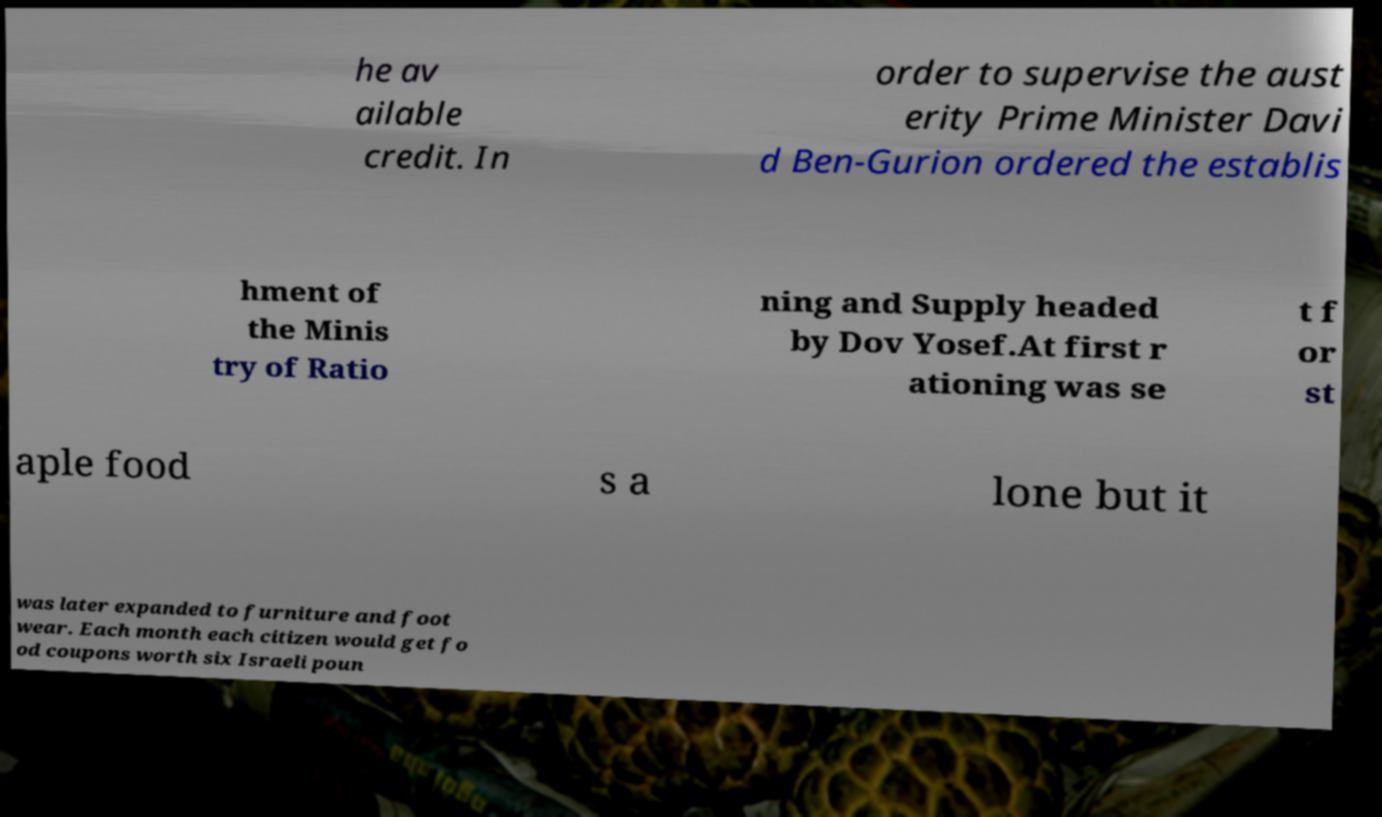For documentation purposes, I need the text within this image transcribed. Could you provide that? he av ailable credit. In order to supervise the aust erity Prime Minister Davi d Ben-Gurion ordered the establis hment of the Minis try of Ratio ning and Supply headed by Dov Yosef.At first r ationing was se t f or st aple food s a lone but it was later expanded to furniture and foot wear. Each month each citizen would get fo od coupons worth six Israeli poun 